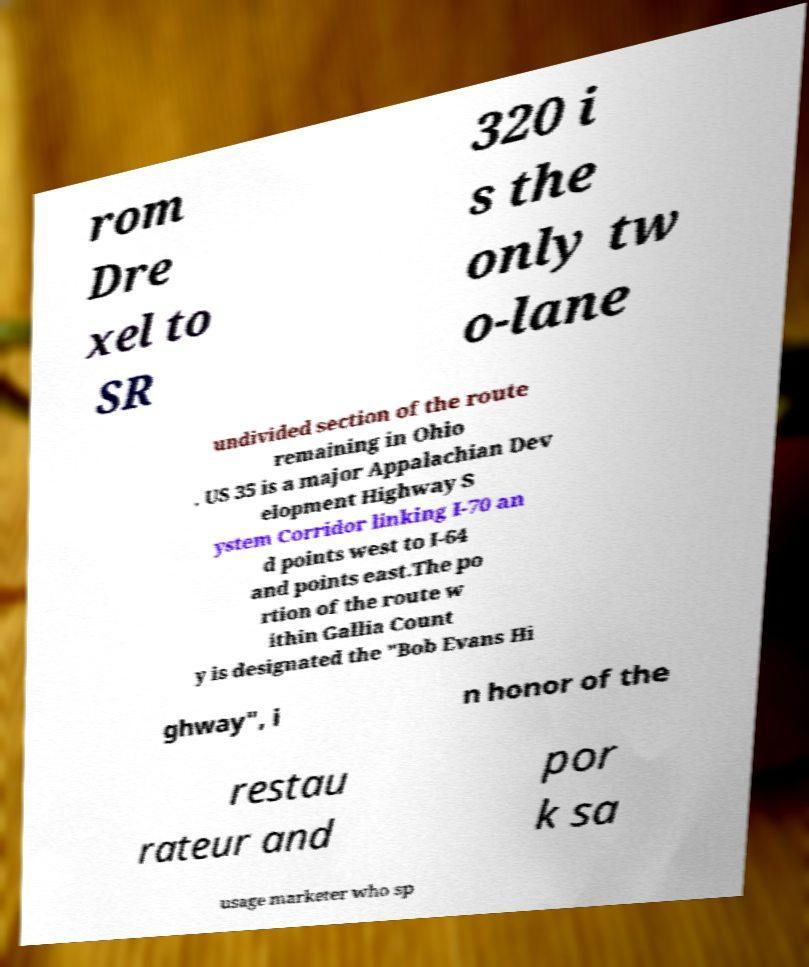Could you assist in decoding the text presented in this image and type it out clearly? rom Dre xel to SR 320 i s the only tw o-lane undivided section of the route remaining in Ohio . US 35 is a major Appalachian Dev elopment Highway S ystem Corridor linking I-70 an d points west to I-64 and points east.The po rtion of the route w ithin Gallia Count y is designated the "Bob Evans Hi ghway", i n honor of the restau rateur and por k sa usage marketer who sp 